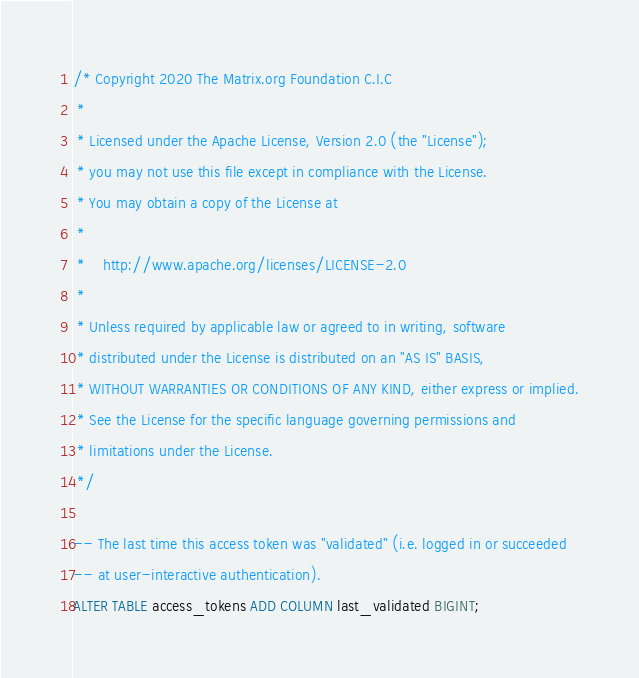<code> <loc_0><loc_0><loc_500><loc_500><_SQL_>/* Copyright 2020 The Matrix.org Foundation C.I.C
 *
 * Licensed under the Apache License, Version 2.0 (the "License");
 * you may not use this file except in compliance with the License.
 * You may obtain a copy of the License at
 *
 *    http://www.apache.org/licenses/LICENSE-2.0
 *
 * Unless required by applicable law or agreed to in writing, software
 * distributed under the License is distributed on an "AS IS" BASIS,
 * WITHOUT WARRANTIES OR CONDITIONS OF ANY KIND, either express or implied.
 * See the License for the specific language governing permissions and
 * limitations under the License.
 */

-- The last time this access token was "validated" (i.e. logged in or succeeded
-- at user-interactive authentication).
ALTER TABLE access_tokens ADD COLUMN last_validated BIGINT;
</code> 